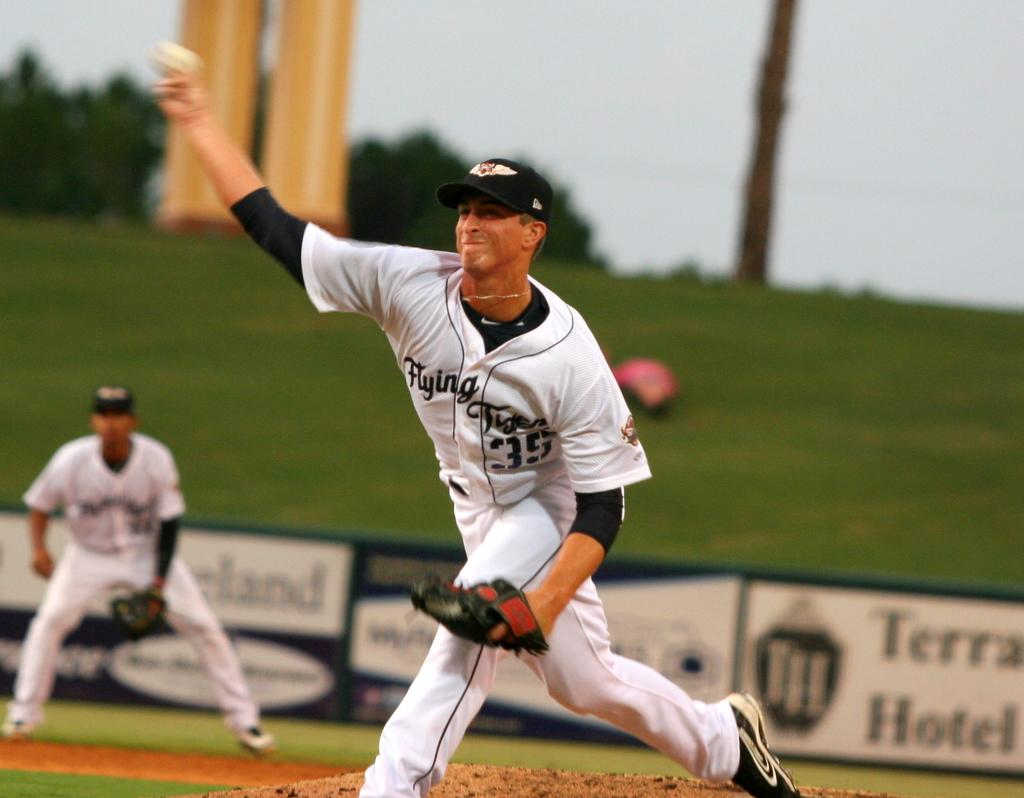<image>
Relay a brief, clear account of the picture shown. The Flying Tigers are a minor league baseball team. 